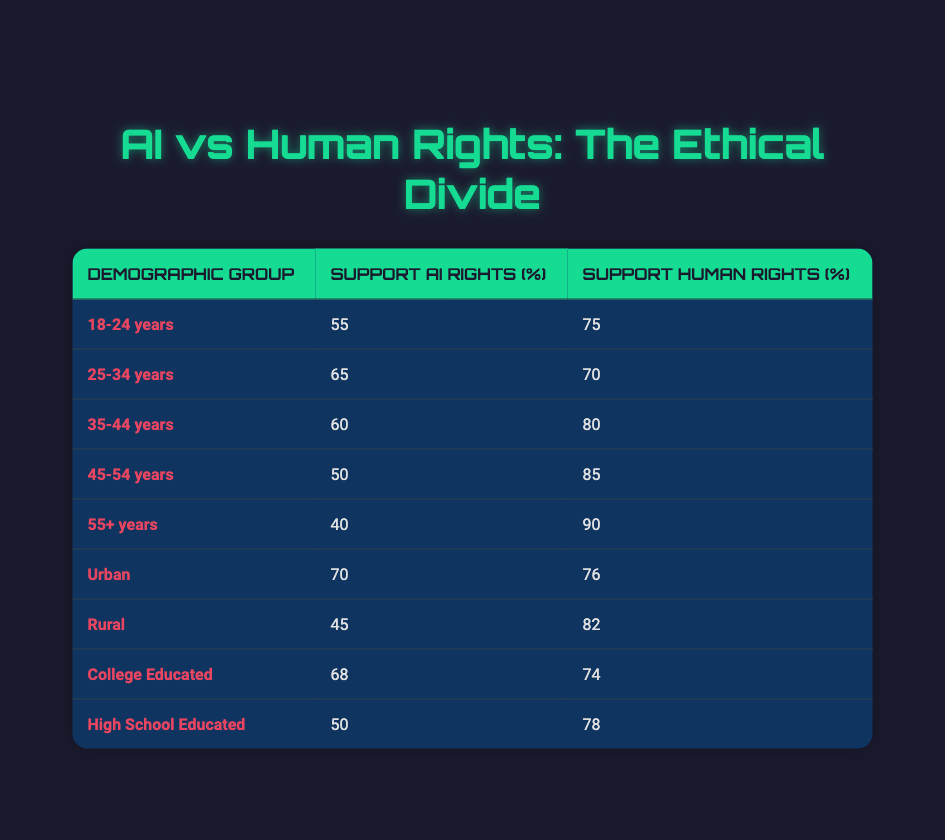What percentage of the 18-24 age group supports AI rights? According to the table, the support for AI rights among the 18-24 age group is 55%.
Answer: 55% What is the support for human rights among college-educated individuals? The table indicates that 74% of college-educated individuals support human rights.
Answer: 74% Which demographic group has the highest support for human rights? The 55+ years age group has the highest support for human rights at 90%.
Answer: 90% What is the difference in support for AI rights between the 45-54 and 55+ age groups? The support for AI rights in the 45-54 age group is 50%, while in the 55+ age group it is 40%. The difference is 50% - 40% = 10%.
Answer: 10% Is support for AI rights among rural individuals lower than that of urban individuals? Yes, rural individuals support AI rights at 45%, while urban individuals support it at 70%.
Answer: Yes What is the average support for AI rights across all age demographics? There are five age groups with support percentages of 55, 65, 60, 50, and 40. The sum is 55 + 65 + 60 + 50 + 40 = 270. Dividing by 5 gives an average of 270 / 5 = 54%.
Answer: 54% Are there more urban individuals supporting human rights than rural individuals? Yes, urban individuals support human rights at 76%, while rural individuals support it at 82%. Thus, we can confirm that urban support is less.
Answer: No What is the total support for human rights from the 25-34 age group and the college educated group? The 25-34 age group supports human rights at 70%, and college-educated individuals at 74%. Adding these gives a total of 70% + 74% = 144%.
Answer: 144% Which demographic group has the lowest support for AI rights? The demographic group with the lowest support for AI rights is the 55+ age group at 40%.
Answer: 40% 